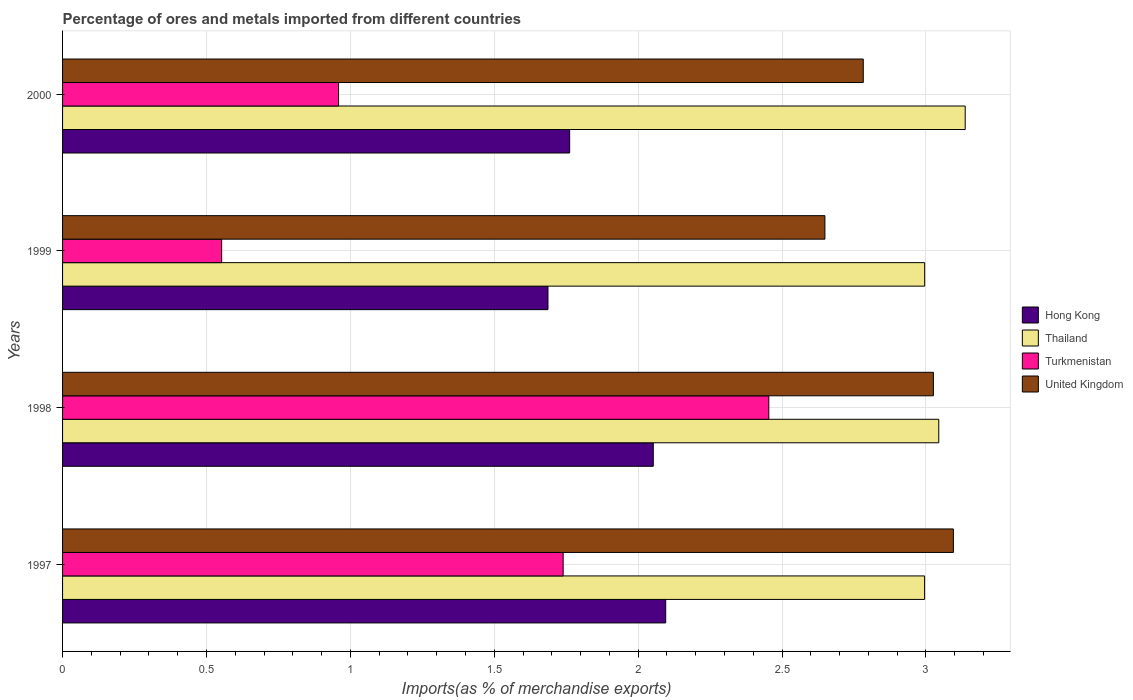How many different coloured bars are there?
Make the answer very short. 4. Are the number of bars per tick equal to the number of legend labels?
Your answer should be compact. Yes. What is the label of the 3rd group of bars from the top?
Offer a very short reply. 1998. In how many cases, is the number of bars for a given year not equal to the number of legend labels?
Offer a terse response. 0. What is the percentage of imports to different countries in Thailand in 1999?
Your response must be concise. 3. Across all years, what is the maximum percentage of imports to different countries in United Kingdom?
Provide a short and direct response. 3.1. Across all years, what is the minimum percentage of imports to different countries in Hong Kong?
Your response must be concise. 1.69. In which year was the percentage of imports to different countries in Hong Kong maximum?
Keep it short and to the point. 1997. What is the total percentage of imports to different countries in Hong Kong in the graph?
Make the answer very short. 7.6. What is the difference between the percentage of imports to different countries in Turkmenistan in 1997 and that in 2000?
Keep it short and to the point. 0.78. What is the difference between the percentage of imports to different countries in Thailand in 1998 and the percentage of imports to different countries in Turkmenistan in 1997?
Provide a short and direct response. 1.31. What is the average percentage of imports to different countries in Hong Kong per year?
Offer a very short reply. 1.9. In the year 1997, what is the difference between the percentage of imports to different countries in Thailand and percentage of imports to different countries in Hong Kong?
Ensure brevity in your answer.  0.9. In how many years, is the percentage of imports to different countries in Turkmenistan greater than 1.3 %?
Give a very brief answer. 2. What is the ratio of the percentage of imports to different countries in Hong Kong in 1997 to that in 2000?
Offer a very short reply. 1.19. Is the percentage of imports to different countries in Turkmenistan in 1997 less than that in 1999?
Ensure brevity in your answer.  No. Is the difference between the percentage of imports to different countries in Thailand in 1997 and 1999 greater than the difference between the percentage of imports to different countries in Hong Kong in 1997 and 1999?
Provide a short and direct response. No. What is the difference between the highest and the second highest percentage of imports to different countries in Thailand?
Your answer should be very brief. 0.09. What is the difference between the highest and the lowest percentage of imports to different countries in Hong Kong?
Your answer should be compact. 0.41. Is it the case that in every year, the sum of the percentage of imports to different countries in Thailand and percentage of imports to different countries in United Kingdom is greater than the sum of percentage of imports to different countries in Turkmenistan and percentage of imports to different countries in Hong Kong?
Your answer should be compact. Yes. What does the 3rd bar from the top in 1999 represents?
Provide a succinct answer. Thailand. What does the 2nd bar from the bottom in 1997 represents?
Provide a short and direct response. Thailand. How many bars are there?
Your answer should be compact. 16. Are all the bars in the graph horizontal?
Make the answer very short. Yes. How many years are there in the graph?
Make the answer very short. 4. What is the difference between two consecutive major ticks on the X-axis?
Your response must be concise. 0.5. Does the graph contain any zero values?
Give a very brief answer. No. Does the graph contain grids?
Offer a very short reply. Yes. How many legend labels are there?
Your answer should be very brief. 4. How are the legend labels stacked?
Ensure brevity in your answer.  Vertical. What is the title of the graph?
Your response must be concise. Percentage of ores and metals imported from different countries. Does "Brunei Darussalam" appear as one of the legend labels in the graph?
Offer a very short reply. No. What is the label or title of the X-axis?
Offer a terse response. Imports(as % of merchandise exports). What is the label or title of the Y-axis?
Your response must be concise. Years. What is the Imports(as % of merchandise exports) in Hong Kong in 1997?
Give a very brief answer. 2.1. What is the Imports(as % of merchandise exports) of Thailand in 1997?
Your answer should be very brief. 3. What is the Imports(as % of merchandise exports) of Turkmenistan in 1997?
Provide a succinct answer. 1.74. What is the Imports(as % of merchandise exports) of United Kingdom in 1997?
Give a very brief answer. 3.1. What is the Imports(as % of merchandise exports) in Hong Kong in 1998?
Provide a short and direct response. 2.05. What is the Imports(as % of merchandise exports) of Thailand in 1998?
Your response must be concise. 3.04. What is the Imports(as % of merchandise exports) in Turkmenistan in 1998?
Provide a succinct answer. 2.45. What is the Imports(as % of merchandise exports) of United Kingdom in 1998?
Ensure brevity in your answer.  3.03. What is the Imports(as % of merchandise exports) in Hong Kong in 1999?
Provide a short and direct response. 1.69. What is the Imports(as % of merchandise exports) of Thailand in 1999?
Your response must be concise. 3. What is the Imports(as % of merchandise exports) of Turkmenistan in 1999?
Your response must be concise. 0.55. What is the Imports(as % of merchandise exports) in United Kingdom in 1999?
Provide a succinct answer. 2.65. What is the Imports(as % of merchandise exports) in Hong Kong in 2000?
Your response must be concise. 1.76. What is the Imports(as % of merchandise exports) of Thailand in 2000?
Keep it short and to the point. 3.14. What is the Imports(as % of merchandise exports) in Turkmenistan in 2000?
Provide a succinct answer. 0.96. What is the Imports(as % of merchandise exports) of United Kingdom in 2000?
Your answer should be very brief. 2.78. Across all years, what is the maximum Imports(as % of merchandise exports) of Hong Kong?
Your answer should be compact. 2.1. Across all years, what is the maximum Imports(as % of merchandise exports) in Thailand?
Make the answer very short. 3.14. Across all years, what is the maximum Imports(as % of merchandise exports) of Turkmenistan?
Your answer should be compact. 2.45. Across all years, what is the maximum Imports(as % of merchandise exports) in United Kingdom?
Give a very brief answer. 3.1. Across all years, what is the minimum Imports(as % of merchandise exports) in Hong Kong?
Make the answer very short. 1.69. Across all years, what is the minimum Imports(as % of merchandise exports) of Thailand?
Your answer should be very brief. 3. Across all years, what is the minimum Imports(as % of merchandise exports) of Turkmenistan?
Give a very brief answer. 0.55. Across all years, what is the minimum Imports(as % of merchandise exports) in United Kingdom?
Provide a succinct answer. 2.65. What is the total Imports(as % of merchandise exports) of Hong Kong in the graph?
Offer a very short reply. 7.6. What is the total Imports(as % of merchandise exports) in Thailand in the graph?
Ensure brevity in your answer.  12.17. What is the total Imports(as % of merchandise exports) of Turkmenistan in the graph?
Your response must be concise. 5.71. What is the total Imports(as % of merchandise exports) in United Kingdom in the graph?
Keep it short and to the point. 11.55. What is the difference between the Imports(as % of merchandise exports) in Hong Kong in 1997 and that in 1998?
Your response must be concise. 0.04. What is the difference between the Imports(as % of merchandise exports) of Thailand in 1997 and that in 1998?
Give a very brief answer. -0.05. What is the difference between the Imports(as % of merchandise exports) in Turkmenistan in 1997 and that in 1998?
Your response must be concise. -0.71. What is the difference between the Imports(as % of merchandise exports) in United Kingdom in 1997 and that in 1998?
Make the answer very short. 0.07. What is the difference between the Imports(as % of merchandise exports) of Hong Kong in 1997 and that in 1999?
Your response must be concise. 0.41. What is the difference between the Imports(as % of merchandise exports) in Thailand in 1997 and that in 1999?
Provide a succinct answer. -0. What is the difference between the Imports(as % of merchandise exports) in Turkmenistan in 1997 and that in 1999?
Offer a very short reply. 1.19. What is the difference between the Imports(as % of merchandise exports) in United Kingdom in 1997 and that in 1999?
Make the answer very short. 0.45. What is the difference between the Imports(as % of merchandise exports) in Hong Kong in 1997 and that in 2000?
Make the answer very short. 0.33. What is the difference between the Imports(as % of merchandise exports) of Thailand in 1997 and that in 2000?
Offer a terse response. -0.14. What is the difference between the Imports(as % of merchandise exports) in Turkmenistan in 1997 and that in 2000?
Keep it short and to the point. 0.78. What is the difference between the Imports(as % of merchandise exports) of United Kingdom in 1997 and that in 2000?
Your answer should be compact. 0.31. What is the difference between the Imports(as % of merchandise exports) in Hong Kong in 1998 and that in 1999?
Give a very brief answer. 0.37. What is the difference between the Imports(as % of merchandise exports) of Thailand in 1998 and that in 1999?
Give a very brief answer. 0.05. What is the difference between the Imports(as % of merchandise exports) in Turkmenistan in 1998 and that in 1999?
Provide a succinct answer. 1.9. What is the difference between the Imports(as % of merchandise exports) of United Kingdom in 1998 and that in 1999?
Your response must be concise. 0.38. What is the difference between the Imports(as % of merchandise exports) of Hong Kong in 1998 and that in 2000?
Ensure brevity in your answer.  0.29. What is the difference between the Imports(as % of merchandise exports) of Thailand in 1998 and that in 2000?
Keep it short and to the point. -0.09. What is the difference between the Imports(as % of merchandise exports) of Turkmenistan in 1998 and that in 2000?
Make the answer very short. 1.5. What is the difference between the Imports(as % of merchandise exports) of United Kingdom in 1998 and that in 2000?
Ensure brevity in your answer.  0.24. What is the difference between the Imports(as % of merchandise exports) in Hong Kong in 1999 and that in 2000?
Your response must be concise. -0.08. What is the difference between the Imports(as % of merchandise exports) in Thailand in 1999 and that in 2000?
Your answer should be compact. -0.14. What is the difference between the Imports(as % of merchandise exports) of Turkmenistan in 1999 and that in 2000?
Give a very brief answer. -0.41. What is the difference between the Imports(as % of merchandise exports) of United Kingdom in 1999 and that in 2000?
Your answer should be compact. -0.13. What is the difference between the Imports(as % of merchandise exports) in Hong Kong in 1997 and the Imports(as % of merchandise exports) in Thailand in 1998?
Make the answer very short. -0.95. What is the difference between the Imports(as % of merchandise exports) in Hong Kong in 1997 and the Imports(as % of merchandise exports) in Turkmenistan in 1998?
Provide a succinct answer. -0.36. What is the difference between the Imports(as % of merchandise exports) in Hong Kong in 1997 and the Imports(as % of merchandise exports) in United Kingdom in 1998?
Provide a succinct answer. -0.93. What is the difference between the Imports(as % of merchandise exports) in Thailand in 1997 and the Imports(as % of merchandise exports) in Turkmenistan in 1998?
Give a very brief answer. 0.54. What is the difference between the Imports(as % of merchandise exports) in Thailand in 1997 and the Imports(as % of merchandise exports) in United Kingdom in 1998?
Keep it short and to the point. -0.03. What is the difference between the Imports(as % of merchandise exports) of Turkmenistan in 1997 and the Imports(as % of merchandise exports) of United Kingdom in 1998?
Keep it short and to the point. -1.29. What is the difference between the Imports(as % of merchandise exports) of Hong Kong in 1997 and the Imports(as % of merchandise exports) of Thailand in 1999?
Your answer should be very brief. -0.9. What is the difference between the Imports(as % of merchandise exports) in Hong Kong in 1997 and the Imports(as % of merchandise exports) in Turkmenistan in 1999?
Provide a succinct answer. 1.54. What is the difference between the Imports(as % of merchandise exports) in Hong Kong in 1997 and the Imports(as % of merchandise exports) in United Kingdom in 1999?
Make the answer very short. -0.55. What is the difference between the Imports(as % of merchandise exports) in Thailand in 1997 and the Imports(as % of merchandise exports) in Turkmenistan in 1999?
Your answer should be very brief. 2.44. What is the difference between the Imports(as % of merchandise exports) in Thailand in 1997 and the Imports(as % of merchandise exports) in United Kingdom in 1999?
Keep it short and to the point. 0.35. What is the difference between the Imports(as % of merchandise exports) in Turkmenistan in 1997 and the Imports(as % of merchandise exports) in United Kingdom in 1999?
Offer a terse response. -0.91. What is the difference between the Imports(as % of merchandise exports) of Hong Kong in 1997 and the Imports(as % of merchandise exports) of Thailand in 2000?
Ensure brevity in your answer.  -1.04. What is the difference between the Imports(as % of merchandise exports) of Hong Kong in 1997 and the Imports(as % of merchandise exports) of Turkmenistan in 2000?
Offer a terse response. 1.14. What is the difference between the Imports(as % of merchandise exports) of Hong Kong in 1997 and the Imports(as % of merchandise exports) of United Kingdom in 2000?
Your answer should be compact. -0.69. What is the difference between the Imports(as % of merchandise exports) in Thailand in 1997 and the Imports(as % of merchandise exports) in Turkmenistan in 2000?
Offer a terse response. 2.04. What is the difference between the Imports(as % of merchandise exports) of Thailand in 1997 and the Imports(as % of merchandise exports) of United Kingdom in 2000?
Your answer should be compact. 0.21. What is the difference between the Imports(as % of merchandise exports) of Turkmenistan in 1997 and the Imports(as % of merchandise exports) of United Kingdom in 2000?
Give a very brief answer. -1.04. What is the difference between the Imports(as % of merchandise exports) of Hong Kong in 1998 and the Imports(as % of merchandise exports) of Thailand in 1999?
Provide a succinct answer. -0.94. What is the difference between the Imports(as % of merchandise exports) of Hong Kong in 1998 and the Imports(as % of merchandise exports) of Turkmenistan in 1999?
Provide a short and direct response. 1.5. What is the difference between the Imports(as % of merchandise exports) of Hong Kong in 1998 and the Imports(as % of merchandise exports) of United Kingdom in 1999?
Provide a short and direct response. -0.6. What is the difference between the Imports(as % of merchandise exports) of Thailand in 1998 and the Imports(as % of merchandise exports) of Turkmenistan in 1999?
Ensure brevity in your answer.  2.49. What is the difference between the Imports(as % of merchandise exports) of Thailand in 1998 and the Imports(as % of merchandise exports) of United Kingdom in 1999?
Your response must be concise. 0.4. What is the difference between the Imports(as % of merchandise exports) in Turkmenistan in 1998 and the Imports(as % of merchandise exports) in United Kingdom in 1999?
Offer a very short reply. -0.2. What is the difference between the Imports(as % of merchandise exports) in Hong Kong in 1998 and the Imports(as % of merchandise exports) in Thailand in 2000?
Offer a very short reply. -1.08. What is the difference between the Imports(as % of merchandise exports) in Hong Kong in 1998 and the Imports(as % of merchandise exports) in Turkmenistan in 2000?
Offer a very short reply. 1.09. What is the difference between the Imports(as % of merchandise exports) in Hong Kong in 1998 and the Imports(as % of merchandise exports) in United Kingdom in 2000?
Make the answer very short. -0.73. What is the difference between the Imports(as % of merchandise exports) of Thailand in 1998 and the Imports(as % of merchandise exports) of Turkmenistan in 2000?
Your answer should be very brief. 2.09. What is the difference between the Imports(as % of merchandise exports) in Thailand in 1998 and the Imports(as % of merchandise exports) in United Kingdom in 2000?
Your answer should be compact. 0.26. What is the difference between the Imports(as % of merchandise exports) of Turkmenistan in 1998 and the Imports(as % of merchandise exports) of United Kingdom in 2000?
Provide a succinct answer. -0.33. What is the difference between the Imports(as % of merchandise exports) of Hong Kong in 1999 and the Imports(as % of merchandise exports) of Thailand in 2000?
Offer a very short reply. -1.45. What is the difference between the Imports(as % of merchandise exports) in Hong Kong in 1999 and the Imports(as % of merchandise exports) in Turkmenistan in 2000?
Give a very brief answer. 0.73. What is the difference between the Imports(as % of merchandise exports) in Hong Kong in 1999 and the Imports(as % of merchandise exports) in United Kingdom in 2000?
Make the answer very short. -1.1. What is the difference between the Imports(as % of merchandise exports) of Thailand in 1999 and the Imports(as % of merchandise exports) of Turkmenistan in 2000?
Make the answer very short. 2.04. What is the difference between the Imports(as % of merchandise exports) of Thailand in 1999 and the Imports(as % of merchandise exports) of United Kingdom in 2000?
Provide a succinct answer. 0.21. What is the difference between the Imports(as % of merchandise exports) of Turkmenistan in 1999 and the Imports(as % of merchandise exports) of United Kingdom in 2000?
Your answer should be compact. -2.23. What is the average Imports(as % of merchandise exports) of Hong Kong per year?
Your answer should be compact. 1.9. What is the average Imports(as % of merchandise exports) of Thailand per year?
Ensure brevity in your answer.  3.04. What is the average Imports(as % of merchandise exports) of Turkmenistan per year?
Your answer should be compact. 1.43. What is the average Imports(as % of merchandise exports) of United Kingdom per year?
Your answer should be very brief. 2.89. In the year 1997, what is the difference between the Imports(as % of merchandise exports) of Hong Kong and Imports(as % of merchandise exports) of Thailand?
Provide a short and direct response. -0.9. In the year 1997, what is the difference between the Imports(as % of merchandise exports) in Hong Kong and Imports(as % of merchandise exports) in Turkmenistan?
Give a very brief answer. 0.36. In the year 1997, what is the difference between the Imports(as % of merchandise exports) of Hong Kong and Imports(as % of merchandise exports) of United Kingdom?
Give a very brief answer. -1. In the year 1997, what is the difference between the Imports(as % of merchandise exports) of Thailand and Imports(as % of merchandise exports) of Turkmenistan?
Your answer should be compact. 1.26. In the year 1997, what is the difference between the Imports(as % of merchandise exports) in Thailand and Imports(as % of merchandise exports) in United Kingdom?
Offer a terse response. -0.1. In the year 1997, what is the difference between the Imports(as % of merchandise exports) in Turkmenistan and Imports(as % of merchandise exports) in United Kingdom?
Provide a short and direct response. -1.36. In the year 1998, what is the difference between the Imports(as % of merchandise exports) in Hong Kong and Imports(as % of merchandise exports) in Thailand?
Keep it short and to the point. -0.99. In the year 1998, what is the difference between the Imports(as % of merchandise exports) of Hong Kong and Imports(as % of merchandise exports) of Turkmenistan?
Make the answer very short. -0.4. In the year 1998, what is the difference between the Imports(as % of merchandise exports) of Hong Kong and Imports(as % of merchandise exports) of United Kingdom?
Provide a succinct answer. -0.97. In the year 1998, what is the difference between the Imports(as % of merchandise exports) of Thailand and Imports(as % of merchandise exports) of Turkmenistan?
Make the answer very short. 0.59. In the year 1998, what is the difference between the Imports(as % of merchandise exports) in Thailand and Imports(as % of merchandise exports) in United Kingdom?
Give a very brief answer. 0.02. In the year 1998, what is the difference between the Imports(as % of merchandise exports) of Turkmenistan and Imports(as % of merchandise exports) of United Kingdom?
Offer a very short reply. -0.57. In the year 1999, what is the difference between the Imports(as % of merchandise exports) in Hong Kong and Imports(as % of merchandise exports) in Thailand?
Keep it short and to the point. -1.31. In the year 1999, what is the difference between the Imports(as % of merchandise exports) in Hong Kong and Imports(as % of merchandise exports) in Turkmenistan?
Offer a very short reply. 1.13. In the year 1999, what is the difference between the Imports(as % of merchandise exports) of Hong Kong and Imports(as % of merchandise exports) of United Kingdom?
Offer a terse response. -0.96. In the year 1999, what is the difference between the Imports(as % of merchandise exports) in Thailand and Imports(as % of merchandise exports) in Turkmenistan?
Your answer should be compact. 2.44. In the year 1999, what is the difference between the Imports(as % of merchandise exports) of Thailand and Imports(as % of merchandise exports) of United Kingdom?
Give a very brief answer. 0.35. In the year 1999, what is the difference between the Imports(as % of merchandise exports) in Turkmenistan and Imports(as % of merchandise exports) in United Kingdom?
Your answer should be very brief. -2.1. In the year 2000, what is the difference between the Imports(as % of merchandise exports) of Hong Kong and Imports(as % of merchandise exports) of Thailand?
Provide a succinct answer. -1.37. In the year 2000, what is the difference between the Imports(as % of merchandise exports) of Hong Kong and Imports(as % of merchandise exports) of Turkmenistan?
Your answer should be compact. 0.8. In the year 2000, what is the difference between the Imports(as % of merchandise exports) of Hong Kong and Imports(as % of merchandise exports) of United Kingdom?
Offer a terse response. -1.02. In the year 2000, what is the difference between the Imports(as % of merchandise exports) of Thailand and Imports(as % of merchandise exports) of Turkmenistan?
Your answer should be compact. 2.18. In the year 2000, what is the difference between the Imports(as % of merchandise exports) in Thailand and Imports(as % of merchandise exports) in United Kingdom?
Give a very brief answer. 0.35. In the year 2000, what is the difference between the Imports(as % of merchandise exports) of Turkmenistan and Imports(as % of merchandise exports) of United Kingdom?
Provide a short and direct response. -1.82. What is the ratio of the Imports(as % of merchandise exports) of Thailand in 1997 to that in 1998?
Keep it short and to the point. 0.98. What is the ratio of the Imports(as % of merchandise exports) in Turkmenistan in 1997 to that in 1998?
Ensure brevity in your answer.  0.71. What is the ratio of the Imports(as % of merchandise exports) of United Kingdom in 1997 to that in 1998?
Ensure brevity in your answer.  1.02. What is the ratio of the Imports(as % of merchandise exports) of Hong Kong in 1997 to that in 1999?
Keep it short and to the point. 1.24. What is the ratio of the Imports(as % of merchandise exports) in Thailand in 1997 to that in 1999?
Provide a succinct answer. 1. What is the ratio of the Imports(as % of merchandise exports) in Turkmenistan in 1997 to that in 1999?
Provide a succinct answer. 3.15. What is the ratio of the Imports(as % of merchandise exports) of United Kingdom in 1997 to that in 1999?
Provide a succinct answer. 1.17. What is the ratio of the Imports(as % of merchandise exports) of Hong Kong in 1997 to that in 2000?
Your answer should be compact. 1.19. What is the ratio of the Imports(as % of merchandise exports) in Thailand in 1997 to that in 2000?
Offer a terse response. 0.95. What is the ratio of the Imports(as % of merchandise exports) in Turkmenistan in 1997 to that in 2000?
Offer a terse response. 1.81. What is the ratio of the Imports(as % of merchandise exports) of United Kingdom in 1997 to that in 2000?
Provide a succinct answer. 1.11. What is the ratio of the Imports(as % of merchandise exports) of Hong Kong in 1998 to that in 1999?
Provide a succinct answer. 1.22. What is the ratio of the Imports(as % of merchandise exports) of Thailand in 1998 to that in 1999?
Keep it short and to the point. 1.02. What is the ratio of the Imports(as % of merchandise exports) of Turkmenistan in 1998 to that in 1999?
Offer a terse response. 4.44. What is the ratio of the Imports(as % of merchandise exports) of United Kingdom in 1998 to that in 1999?
Ensure brevity in your answer.  1.14. What is the ratio of the Imports(as % of merchandise exports) in Hong Kong in 1998 to that in 2000?
Ensure brevity in your answer.  1.16. What is the ratio of the Imports(as % of merchandise exports) in Thailand in 1998 to that in 2000?
Provide a short and direct response. 0.97. What is the ratio of the Imports(as % of merchandise exports) in Turkmenistan in 1998 to that in 2000?
Provide a short and direct response. 2.56. What is the ratio of the Imports(as % of merchandise exports) in United Kingdom in 1998 to that in 2000?
Your response must be concise. 1.09. What is the ratio of the Imports(as % of merchandise exports) of Hong Kong in 1999 to that in 2000?
Give a very brief answer. 0.96. What is the ratio of the Imports(as % of merchandise exports) in Thailand in 1999 to that in 2000?
Your response must be concise. 0.96. What is the ratio of the Imports(as % of merchandise exports) of Turkmenistan in 1999 to that in 2000?
Offer a terse response. 0.58. What is the ratio of the Imports(as % of merchandise exports) in United Kingdom in 1999 to that in 2000?
Offer a terse response. 0.95. What is the difference between the highest and the second highest Imports(as % of merchandise exports) in Hong Kong?
Provide a succinct answer. 0.04. What is the difference between the highest and the second highest Imports(as % of merchandise exports) of Thailand?
Your answer should be very brief. 0.09. What is the difference between the highest and the second highest Imports(as % of merchandise exports) in Turkmenistan?
Ensure brevity in your answer.  0.71. What is the difference between the highest and the second highest Imports(as % of merchandise exports) in United Kingdom?
Offer a very short reply. 0.07. What is the difference between the highest and the lowest Imports(as % of merchandise exports) in Hong Kong?
Ensure brevity in your answer.  0.41. What is the difference between the highest and the lowest Imports(as % of merchandise exports) in Thailand?
Your answer should be very brief. 0.14. What is the difference between the highest and the lowest Imports(as % of merchandise exports) of Turkmenistan?
Your answer should be very brief. 1.9. What is the difference between the highest and the lowest Imports(as % of merchandise exports) of United Kingdom?
Give a very brief answer. 0.45. 